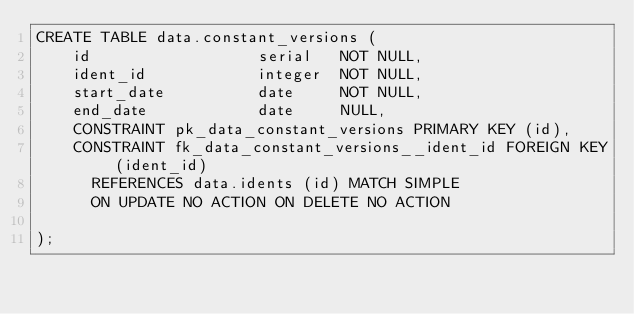<code> <loc_0><loc_0><loc_500><loc_500><_SQL_>CREATE TABLE data.constant_versions (
    id                  serial   NOT NULL,
    ident_id            integer  NOT NULL,
    start_date          date     NOT NULL,
    end_date            date     NULL,
    CONSTRAINT pk_data_constant_versions PRIMARY KEY (id),
    CONSTRAINT fk_data_constant_versions__ident_id FOREIGN KEY (ident_id) 
      REFERENCES data.idents (id) MATCH SIMPLE
      ON UPDATE NO ACTION ON DELETE NO ACTION

);</code> 